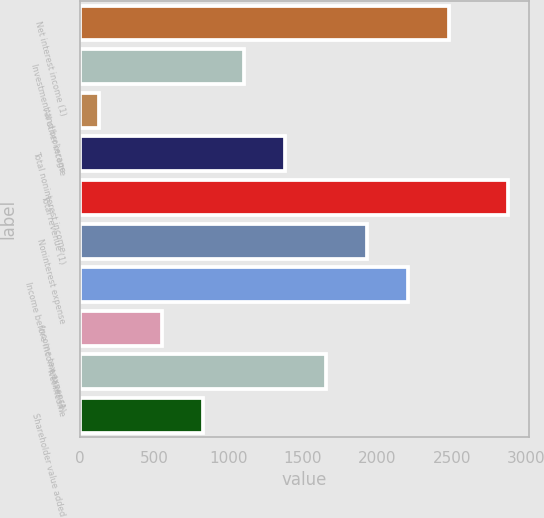Convert chart. <chart><loc_0><loc_0><loc_500><loc_500><bar_chart><fcel>Net interest income (1)<fcel>Investment and brokerage<fcel>All other income<fcel>Total noninterest income<fcel>Total revenue (1)<fcel>Noninterest expense<fcel>Income before income taxes (1)<fcel>Income tax expense<fcel>Net income<fcel>Shareholder value added<nl><fcel>2482.4<fcel>1106.4<fcel>126<fcel>1381.6<fcel>2878<fcel>1932<fcel>2207.2<fcel>556<fcel>1656.8<fcel>831.2<nl></chart> 